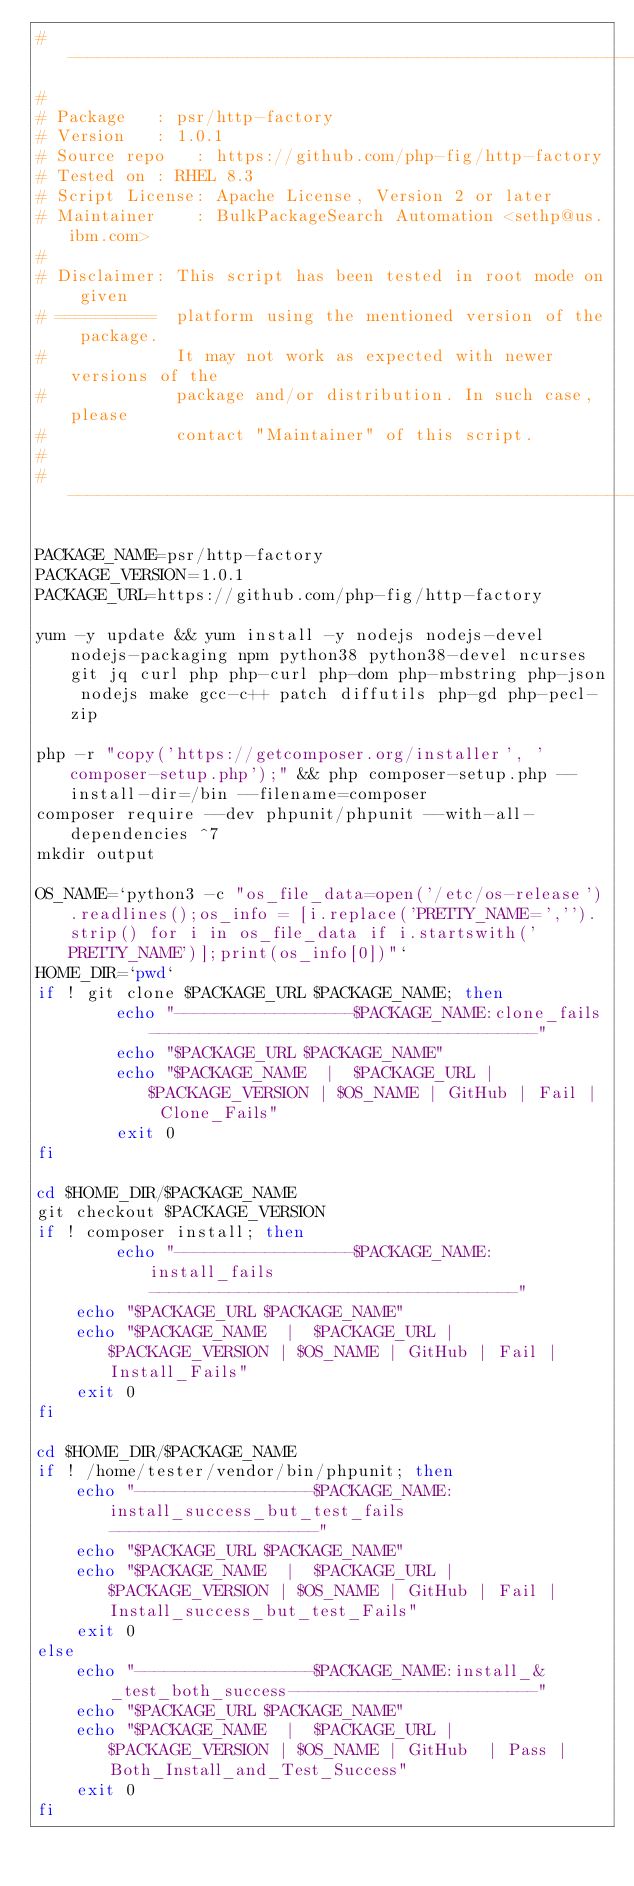<code> <loc_0><loc_0><loc_500><loc_500><_Bash_># -----------------------------------------------------------------------------
#
# Package	: psr/http-factory
# Version	: 1.0.1
# Source repo	: https://github.com/php-fig/http-factory
# Tested on	: RHEL 8.3
# Script License: Apache License, Version 2 or later
# Maintainer	: BulkPackageSearch Automation <sethp@us.ibm.com>
#
# Disclaimer: This script has been tested in root mode on given
# ==========  platform using the mentioned version of the package.
#             It may not work as expected with newer versions of the
#             package and/or distribution. In such case, please
#             contact "Maintainer" of this script.
#
# ----------------------------------------------------------------------------

PACKAGE_NAME=psr/http-factory
PACKAGE_VERSION=1.0.1
PACKAGE_URL=https://github.com/php-fig/http-factory

yum -y update && yum install -y nodejs nodejs-devel nodejs-packaging npm python38 python38-devel ncurses git jq curl php php-curl php-dom php-mbstring php-json nodejs make gcc-c++ patch diffutils php-gd php-pecl-zip

php -r "copy('https://getcomposer.org/installer', 'composer-setup.php');" && php composer-setup.php --install-dir=/bin --filename=composer
composer require --dev phpunit/phpunit --with-all-dependencies ^7
mkdir output

OS_NAME=`python3 -c "os_file_data=open('/etc/os-release').readlines();os_info = [i.replace('PRETTY_NAME=','').strip() for i in os_file_data if i.startswith('PRETTY_NAME')];print(os_info[0])"`
HOME_DIR=`pwd`
if ! git clone $PACKAGE_URL $PACKAGE_NAME; then
    	echo "------------------$PACKAGE_NAME:clone_fails---------------------------------------"
		echo "$PACKAGE_URL $PACKAGE_NAME"
        echo "$PACKAGE_NAME  |  $PACKAGE_URL |  $PACKAGE_VERSION | $OS_NAME | GitHub | Fail |  Clone_Fails"
    	exit 0
fi

cd $HOME_DIR/$PACKAGE_NAME
git checkout $PACKAGE_VERSION
if ! composer install; then
     	echo "------------------$PACKAGE_NAME:install_fails-------------------------------------"
	echo "$PACKAGE_URL $PACKAGE_NAME"
	echo "$PACKAGE_NAME  |  $PACKAGE_URL | $PACKAGE_VERSION | $OS_NAME | GitHub | Fail |  Install_Fails"
	exit 0
fi

cd $HOME_DIR/$PACKAGE_NAME
if ! /home/tester/vendor/bin/phpunit; then
	echo "------------------$PACKAGE_NAME:install_success_but_test_fails---------------------"
	echo "$PACKAGE_URL $PACKAGE_NAME"
	echo "$PACKAGE_NAME  |  $PACKAGE_URL | $PACKAGE_VERSION | $OS_NAME | GitHub | Fail |  Install_success_but_test_Fails"
	exit 0
else
	echo "------------------$PACKAGE_NAME:install_&_test_both_success-------------------------"
	echo "$PACKAGE_URL $PACKAGE_NAME"
	echo "$PACKAGE_NAME  |  $PACKAGE_URL | $PACKAGE_VERSION | $OS_NAME | GitHub  | Pass |  Both_Install_and_Test_Success"
	exit 0
fi</code> 